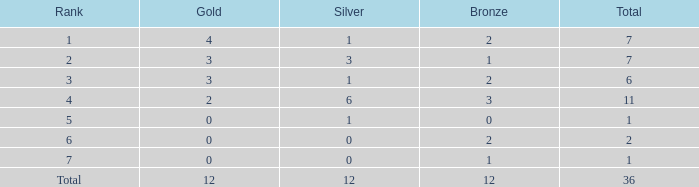What is the number of bronze medals when there are fewer than 0 silver medals? None. 